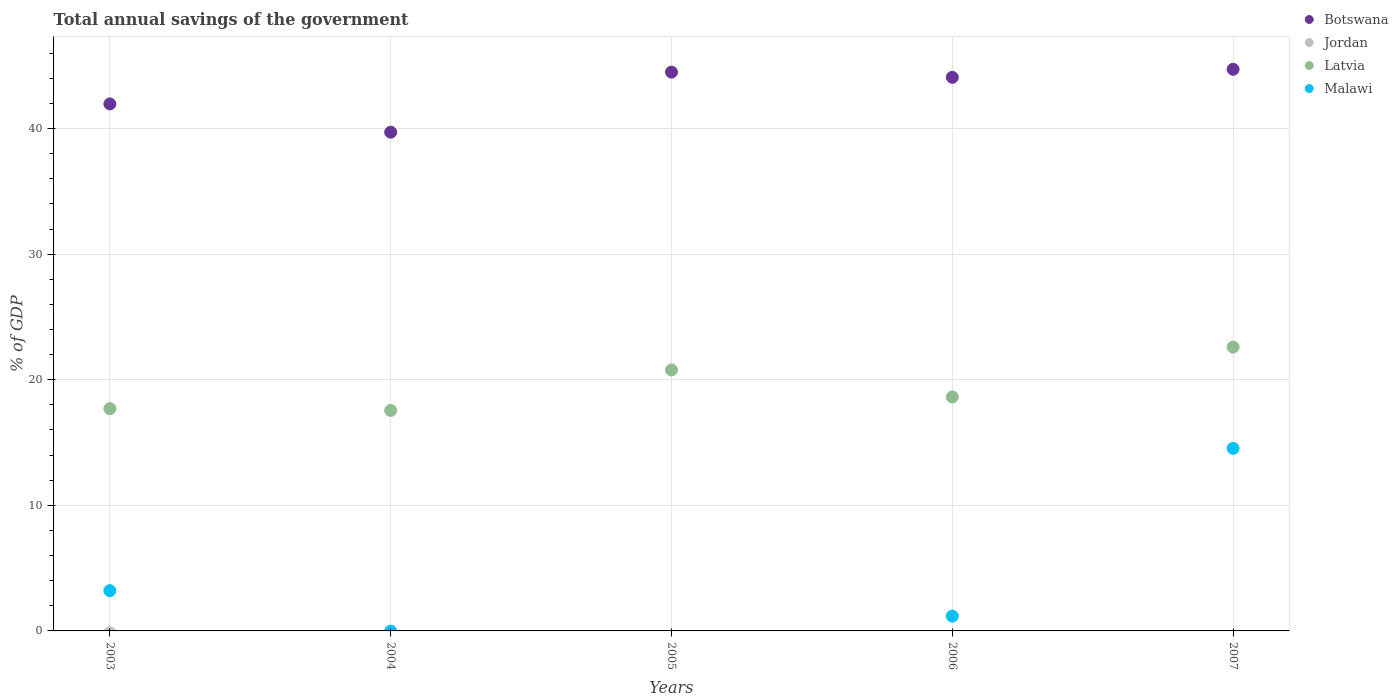Is the number of dotlines equal to the number of legend labels?
Give a very brief answer. No. What is the total annual savings of the government in Malawi in 2006?
Your response must be concise. 1.18. Across all years, what is the maximum total annual savings of the government in Malawi?
Make the answer very short. 14.53. In which year was the total annual savings of the government in Botswana maximum?
Your answer should be compact. 2007. What is the difference between the total annual savings of the government in Botswana in 2005 and that in 2006?
Ensure brevity in your answer.  0.41. What is the difference between the total annual savings of the government in Botswana in 2003 and the total annual savings of the government in Malawi in 2005?
Ensure brevity in your answer.  41.96. What is the average total annual savings of the government in Botswana per year?
Provide a succinct answer. 42.99. In the year 2003, what is the difference between the total annual savings of the government in Botswana and total annual savings of the government in Malawi?
Keep it short and to the point. 38.76. What is the ratio of the total annual savings of the government in Malawi in 2003 to that in 2006?
Your response must be concise. 2.71. Is the total annual savings of the government in Latvia in 2005 less than that in 2006?
Your answer should be compact. No. Is the difference between the total annual savings of the government in Botswana in 2006 and 2007 greater than the difference between the total annual savings of the government in Malawi in 2006 and 2007?
Your response must be concise. Yes. What is the difference between the highest and the second highest total annual savings of the government in Malawi?
Offer a terse response. 11.33. What is the difference between the highest and the lowest total annual savings of the government in Botswana?
Your answer should be compact. 5.01. In how many years, is the total annual savings of the government in Botswana greater than the average total annual savings of the government in Botswana taken over all years?
Provide a succinct answer. 3. Is it the case that in every year, the sum of the total annual savings of the government in Botswana and total annual savings of the government in Latvia  is greater than the total annual savings of the government in Malawi?
Provide a succinct answer. Yes. Does the total annual savings of the government in Jordan monotonically increase over the years?
Your answer should be compact. No. Is the total annual savings of the government in Jordan strictly less than the total annual savings of the government in Latvia over the years?
Offer a terse response. Yes. Does the graph contain any zero values?
Ensure brevity in your answer.  Yes. Does the graph contain grids?
Your response must be concise. Yes. What is the title of the graph?
Ensure brevity in your answer.  Total annual savings of the government. What is the label or title of the Y-axis?
Provide a short and direct response. % of GDP. What is the % of GDP of Botswana in 2003?
Give a very brief answer. 41.96. What is the % of GDP of Latvia in 2003?
Ensure brevity in your answer.  17.7. What is the % of GDP of Malawi in 2003?
Offer a very short reply. 3.2. What is the % of GDP in Botswana in 2004?
Your answer should be compact. 39.71. What is the % of GDP of Jordan in 2004?
Offer a terse response. 0. What is the % of GDP of Latvia in 2004?
Give a very brief answer. 17.55. What is the % of GDP in Malawi in 2004?
Offer a very short reply. 0. What is the % of GDP of Botswana in 2005?
Give a very brief answer. 44.49. What is the % of GDP in Jordan in 2005?
Provide a short and direct response. 0. What is the % of GDP in Latvia in 2005?
Offer a terse response. 20.78. What is the % of GDP in Malawi in 2005?
Make the answer very short. 0. What is the % of GDP in Botswana in 2006?
Your answer should be compact. 44.08. What is the % of GDP in Jordan in 2006?
Your response must be concise. 0. What is the % of GDP in Latvia in 2006?
Ensure brevity in your answer.  18.63. What is the % of GDP in Malawi in 2006?
Your response must be concise. 1.18. What is the % of GDP in Botswana in 2007?
Provide a short and direct response. 44.72. What is the % of GDP in Latvia in 2007?
Your response must be concise. 22.6. What is the % of GDP in Malawi in 2007?
Offer a very short reply. 14.53. Across all years, what is the maximum % of GDP of Botswana?
Provide a short and direct response. 44.72. Across all years, what is the maximum % of GDP of Latvia?
Ensure brevity in your answer.  22.6. Across all years, what is the maximum % of GDP of Malawi?
Offer a very short reply. 14.53. Across all years, what is the minimum % of GDP in Botswana?
Provide a succinct answer. 39.71. Across all years, what is the minimum % of GDP of Latvia?
Ensure brevity in your answer.  17.55. Across all years, what is the minimum % of GDP in Malawi?
Offer a very short reply. 0. What is the total % of GDP in Botswana in the graph?
Provide a succinct answer. 214.96. What is the total % of GDP of Latvia in the graph?
Provide a short and direct response. 97.26. What is the total % of GDP in Malawi in the graph?
Your response must be concise. 18.92. What is the difference between the % of GDP in Botswana in 2003 and that in 2004?
Your answer should be compact. 2.25. What is the difference between the % of GDP in Latvia in 2003 and that in 2004?
Offer a very short reply. 0.14. What is the difference between the % of GDP in Botswana in 2003 and that in 2005?
Keep it short and to the point. -2.53. What is the difference between the % of GDP of Latvia in 2003 and that in 2005?
Keep it short and to the point. -3.09. What is the difference between the % of GDP in Botswana in 2003 and that in 2006?
Your answer should be very brief. -2.12. What is the difference between the % of GDP in Latvia in 2003 and that in 2006?
Keep it short and to the point. -0.93. What is the difference between the % of GDP in Malawi in 2003 and that in 2006?
Make the answer very short. 2.02. What is the difference between the % of GDP in Botswana in 2003 and that in 2007?
Make the answer very short. -2.76. What is the difference between the % of GDP of Latvia in 2003 and that in 2007?
Give a very brief answer. -4.9. What is the difference between the % of GDP in Malawi in 2003 and that in 2007?
Offer a terse response. -11.33. What is the difference between the % of GDP in Botswana in 2004 and that in 2005?
Your answer should be very brief. -4.78. What is the difference between the % of GDP in Latvia in 2004 and that in 2005?
Your answer should be compact. -3.23. What is the difference between the % of GDP of Botswana in 2004 and that in 2006?
Offer a very short reply. -4.37. What is the difference between the % of GDP of Latvia in 2004 and that in 2006?
Offer a terse response. -1.07. What is the difference between the % of GDP of Botswana in 2004 and that in 2007?
Offer a very short reply. -5.01. What is the difference between the % of GDP in Latvia in 2004 and that in 2007?
Your response must be concise. -5.04. What is the difference between the % of GDP in Botswana in 2005 and that in 2006?
Your response must be concise. 0.41. What is the difference between the % of GDP of Latvia in 2005 and that in 2006?
Offer a very short reply. 2.16. What is the difference between the % of GDP in Botswana in 2005 and that in 2007?
Make the answer very short. -0.23. What is the difference between the % of GDP of Latvia in 2005 and that in 2007?
Keep it short and to the point. -1.81. What is the difference between the % of GDP in Botswana in 2006 and that in 2007?
Your answer should be compact. -0.64. What is the difference between the % of GDP of Latvia in 2006 and that in 2007?
Ensure brevity in your answer.  -3.97. What is the difference between the % of GDP in Malawi in 2006 and that in 2007?
Offer a very short reply. -13.35. What is the difference between the % of GDP in Botswana in 2003 and the % of GDP in Latvia in 2004?
Ensure brevity in your answer.  24.41. What is the difference between the % of GDP of Botswana in 2003 and the % of GDP of Latvia in 2005?
Offer a very short reply. 21.18. What is the difference between the % of GDP of Botswana in 2003 and the % of GDP of Latvia in 2006?
Offer a very short reply. 23.34. What is the difference between the % of GDP of Botswana in 2003 and the % of GDP of Malawi in 2006?
Your answer should be compact. 40.78. What is the difference between the % of GDP in Latvia in 2003 and the % of GDP in Malawi in 2006?
Ensure brevity in your answer.  16.51. What is the difference between the % of GDP of Botswana in 2003 and the % of GDP of Latvia in 2007?
Your response must be concise. 19.37. What is the difference between the % of GDP of Botswana in 2003 and the % of GDP of Malawi in 2007?
Provide a succinct answer. 27.43. What is the difference between the % of GDP in Latvia in 2003 and the % of GDP in Malawi in 2007?
Give a very brief answer. 3.16. What is the difference between the % of GDP in Botswana in 2004 and the % of GDP in Latvia in 2005?
Provide a short and direct response. 18.93. What is the difference between the % of GDP in Botswana in 2004 and the % of GDP in Latvia in 2006?
Make the answer very short. 21.08. What is the difference between the % of GDP of Botswana in 2004 and the % of GDP of Malawi in 2006?
Give a very brief answer. 38.53. What is the difference between the % of GDP of Latvia in 2004 and the % of GDP of Malawi in 2006?
Ensure brevity in your answer.  16.37. What is the difference between the % of GDP in Botswana in 2004 and the % of GDP in Latvia in 2007?
Offer a terse response. 17.11. What is the difference between the % of GDP of Botswana in 2004 and the % of GDP of Malawi in 2007?
Provide a short and direct response. 25.17. What is the difference between the % of GDP in Latvia in 2004 and the % of GDP in Malawi in 2007?
Make the answer very short. 3.02. What is the difference between the % of GDP of Botswana in 2005 and the % of GDP of Latvia in 2006?
Your answer should be very brief. 25.86. What is the difference between the % of GDP of Botswana in 2005 and the % of GDP of Malawi in 2006?
Offer a terse response. 43.31. What is the difference between the % of GDP in Latvia in 2005 and the % of GDP in Malawi in 2006?
Your answer should be compact. 19.6. What is the difference between the % of GDP of Botswana in 2005 and the % of GDP of Latvia in 2007?
Provide a succinct answer. 21.9. What is the difference between the % of GDP in Botswana in 2005 and the % of GDP in Malawi in 2007?
Make the answer very short. 29.96. What is the difference between the % of GDP of Latvia in 2005 and the % of GDP of Malawi in 2007?
Provide a short and direct response. 6.25. What is the difference between the % of GDP of Botswana in 2006 and the % of GDP of Latvia in 2007?
Provide a succinct answer. 21.48. What is the difference between the % of GDP of Botswana in 2006 and the % of GDP of Malawi in 2007?
Your response must be concise. 29.54. What is the difference between the % of GDP of Latvia in 2006 and the % of GDP of Malawi in 2007?
Offer a very short reply. 4.09. What is the average % of GDP of Botswana per year?
Provide a short and direct response. 42.99. What is the average % of GDP in Latvia per year?
Your answer should be very brief. 19.45. What is the average % of GDP in Malawi per year?
Keep it short and to the point. 3.78. In the year 2003, what is the difference between the % of GDP in Botswana and % of GDP in Latvia?
Ensure brevity in your answer.  24.27. In the year 2003, what is the difference between the % of GDP of Botswana and % of GDP of Malawi?
Keep it short and to the point. 38.76. In the year 2003, what is the difference between the % of GDP of Latvia and % of GDP of Malawi?
Offer a terse response. 14.49. In the year 2004, what is the difference between the % of GDP of Botswana and % of GDP of Latvia?
Offer a terse response. 22.16. In the year 2005, what is the difference between the % of GDP in Botswana and % of GDP in Latvia?
Your answer should be very brief. 23.71. In the year 2006, what is the difference between the % of GDP in Botswana and % of GDP in Latvia?
Provide a succinct answer. 25.45. In the year 2006, what is the difference between the % of GDP in Botswana and % of GDP in Malawi?
Your response must be concise. 42.9. In the year 2006, what is the difference between the % of GDP in Latvia and % of GDP in Malawi?
Your answer should be compact. 17.45. In the year 2007, what is the difference between the % of GDP of Botswana and % of GDP of Latvia?
Provide a succinct answer. 22.12. In the year 2007, what is the difference between the % of GDP of Botswana and % of GDP of Malawi?
Make the answer very short. 30.19. In the year 2007, what is the difference between the % of GDP in Latvia and % of GDP in Malawi?
Offer a very short reply. 8.06. What is the ratio of the % of GDP of Botswana in 2003 to that in 2004?
Provide a short and direct response. 1.06. What is the ratio of the % of GDP of Latvia in 2003 to that in 2004?
Your response must be concise. 1.01. What is the ratio of the % of GDP in Botswana in 2003 to that in 2005?
Offer a very short reply. 0.94. What is the ratio of the % of GDP of Latvia in 2003 to that in 2005?
Keep it short and to the point. 0.85. What is the ratio of the % of GDP in Botswana in 2003 to that in 2006?
Offer a terse response. 0.95. What is the ratio of the % of GDP of Malawi in 2003 to that in 2006?
Provide a short and direct response. 2.71. What is the ratio of the % of GDP of Botswana in 2003 to that in 2007?
Your answer should be very brief. 0.94. What is the ratio of the % of GDP in Latvia in 2003 to that in 2007?
Offer a very short reply. 0.78. What is the ratio of the % of GDP in Malawi in 2003 to that in 2007?
Offer a very short reply. 0.22. What is the ratio of the % of GDP of Botswana in 2004 to that in 2005?
Your answer should be very brief. 0.89. What is the ratio of the % of GDP of Latvia in 2004 to that in 2005?
Keep it short and to the point. 0.84. What is the ratio of the % of GDP in Botswana in 2004 to that in 2006?
Offer a terse response. 0.9. What is the ratio of the % of GDP of Latvia in 2004 to that in 2006?
Offer a terse response. 0.94. What is the ratio of the % of GDP of Botswana in 2004 to that in 2007?
Your answer should be very brief. 0.89. What is the ratio of the % of GDP of Latvia in 2004 to that in 2007?
Provide a short and direct response. 0.78. What is the ratio of the % of GDP of Botswana in 2005 to that in 2006?
Give a very brief answer. 1.01. What is the ratio of the % of GDP in Latvia in 2005 to that in 2006?
Your response must be concise. 1.12. What is the ratio of the % of GDP in Botswana in 2005 to that in 2007?
Offer a terse response. 0.99. What is the ratio of the % of GDP of Latvia in 2005 to that in 2007?
Provide a succinct answer. 0.92. What is the ratio of the % of GDP in Botswana in 2006 to that in 2007?
Provide a succinct answer. 0.99. What is the ratio of the % of GDP in Latvia in 2006 to that in 2007?
Keep it short and to the point. 0.82. What is the ratio of the % of GDP in Malawi in 2006 to that in 2007?
Keep it short and to the point. 0.08. What is the difference between the highest and the second highest % of GDP of Botswana?
Your response must be concise. 0.23. What is the difference between the highest and the second highest % of GDP of Latvia?
Your response must be concise. 1.81. What is the difference between the highest and the second highest % of GDP in Malawi?
Provide a short and direct response. 11.33. What is the difference between the highest and the lowest % of GDP of Botswana?
Your response must be concise. 5.01. What is the difference between the highest and the lowest % of GDP of Latvia?
Offer a terse response. 5.04. What is the difference between the highest and the lowest % of GDP of Malawi?
Your answer should be compact. 14.53. 